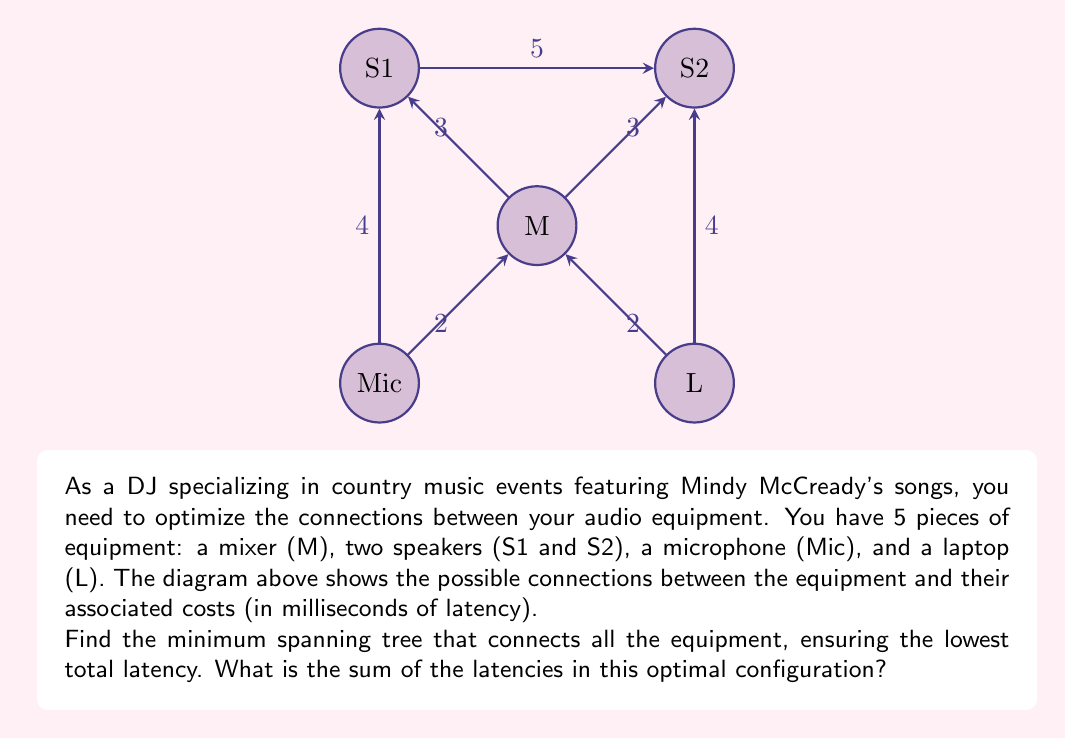Solve this math problem. To solve this problem, we can use Kruskal's algorithm to find the minimum spanning tree of the graph. Here's the step-by-step process:

1) First, list all edges in ascending order of weight (latency):
   - M--S1: 3 ms
   - M--S2: 3 ms
   - Mic--M: 2 ms
   - L--M: 2 ms
   - S1--S2: 5 ms
   - Mic--S1: 4 ms
   - L--S2: 4 ms

2) Start with an empty set of edges and add edges in order, skipping any that would create a cycle:

   - Add Mic--M (2 ms)
   - Add L--M (2 ms)
   - Add M--S1 (3 ms)
   - Add M--S2 (3 ms)

3) At this point, we have connected all vertices (equipment pieces) with 4 edges, which is correct for a minimum spanning tree of 5 vertices.

4) The total latency is the sum of the selected edges:
   $$2 + 2 + 3 + 3 = 10\text{ ms}$$

Therefore, the minimum spanning tree has a total latency of 10 milliseconds.
Answer: 10 ms 